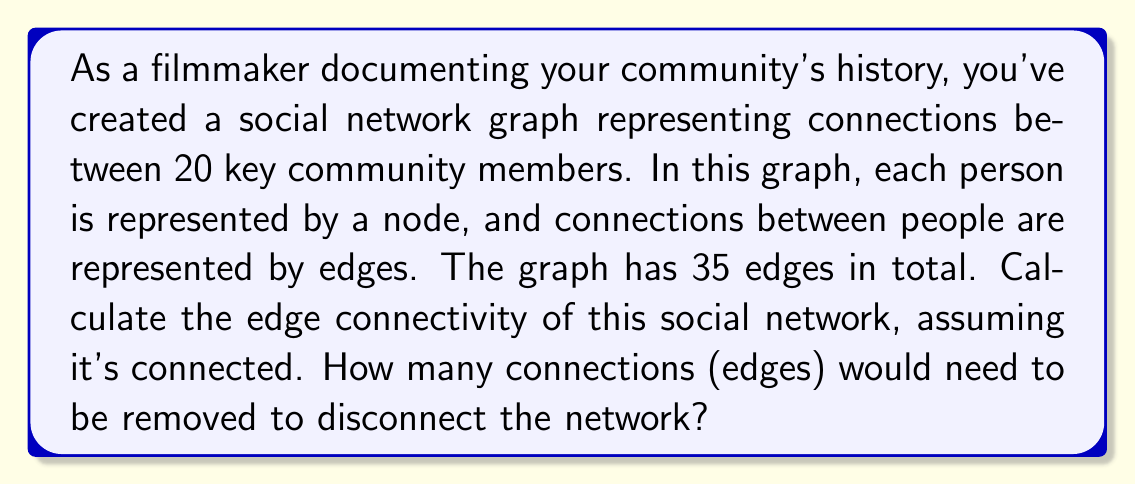What is the answer to this math problem? To solve this problem, we need to understand the concept of edge connectivity in graph theory and apply it to the given social network.

1. Edge connectivity definition:
   The edge connectivity of a graph, denoted as $\lambda(G)$, is the minimum number of edges that need to be removed to disconnect the graph.

2. Given information:
   - Number of nodes (community members): $n = 20$
   - Number of edges (connections): $m = 35$
   - The graph is connected

3. Calculating the edge connectivity:
   For a connected graph, the edge connectivity is always less than or equal to the minimum degree of the graph. 
   
   $$\lambda(G) \leq \delta(G)$$
   
   where $\delta(G)$ is the minimum degree of the graph.

4. Finding the minimum degree:
   The average degree of the graph is:
   
   $$\text{avg degree} = \frac{2m}{n} = \frac{2 \cdot 35}{20} = 3.5$$

   Since the average degree is 3.5, the minimum degree must be less than or equal to 3.

5. Applying the theorem:
   Given that the graph is connected and has 20 nodes, the minimum possible edge connectivity that ensures connectedness is 1.

6. Conclusion:
   The edge connectivity of this social network graph is at least 1 and at most 3.

   $$1 \leq \lambda(G) \leq 3$$

   Without more specific information about the graph structure, we can conclude that removing at least 1 and at most 3 edges would disconnect the network.
Answer: The edge connectivity of the social network is between 1 and 3. At least 1 and at most 3 connections (edges) would need to be removed to disconnect the network. 